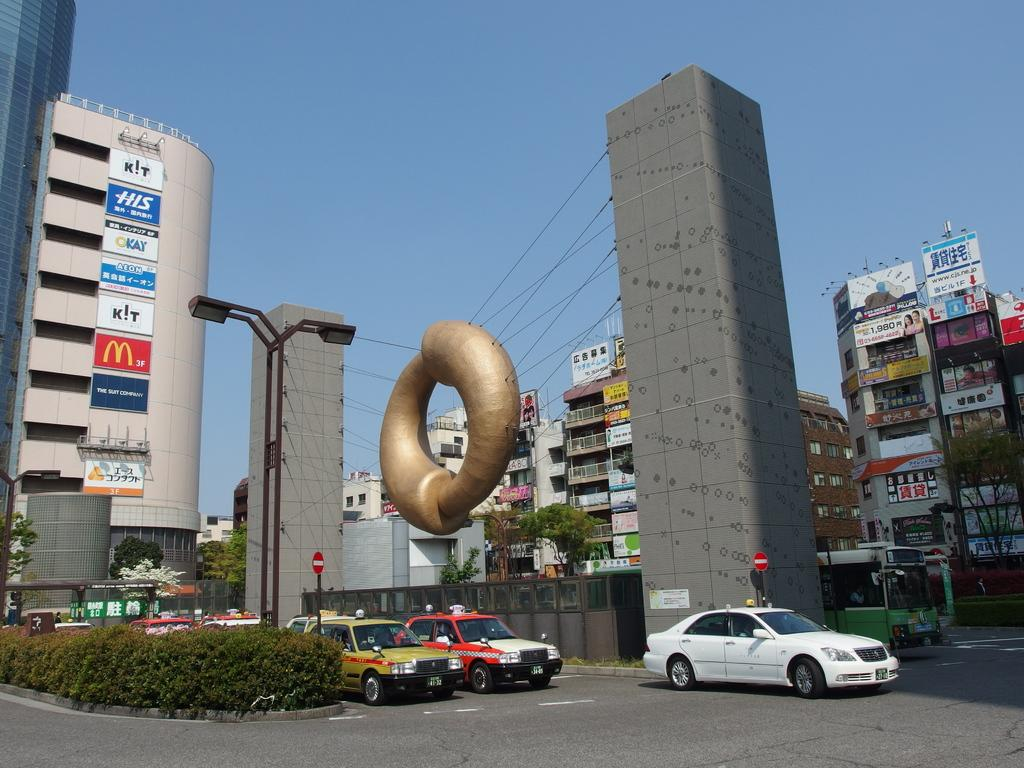<image>
Write a terse but informative summary of the picture. Many signs are on the side of the building including one for McDonald's. 